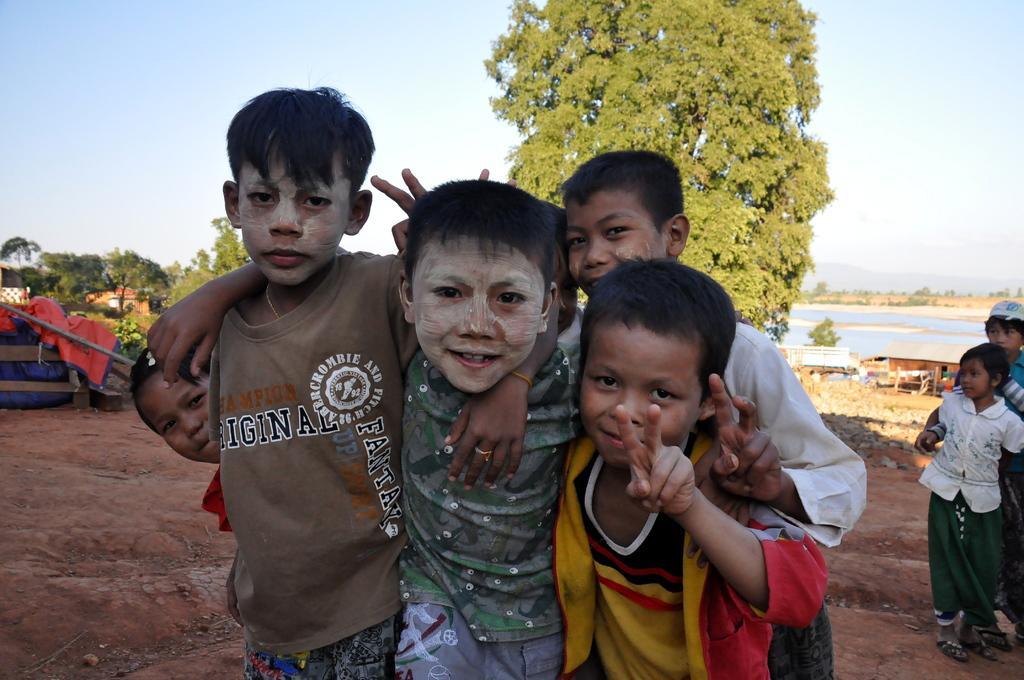Could you give a brief overview of what you see in this image? Children are standing. There are trees and other people at the back. There are benches, sheds and water at the back. 